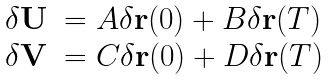Convert formula to latex. <formula><loc_0><loc_0><loc_500><loc_500>\begin{array} { l l } \delta { \mathbf U } & = A \delta { \mathbf r } ( 0 ) + B \delta { \mathbf r } ( T ) \\ \delta { \mathbf V } & = C \delta { \mathbf r } ( 0 ) + D \delta { \mathbf r } ( T ) \end{array}</formula> 